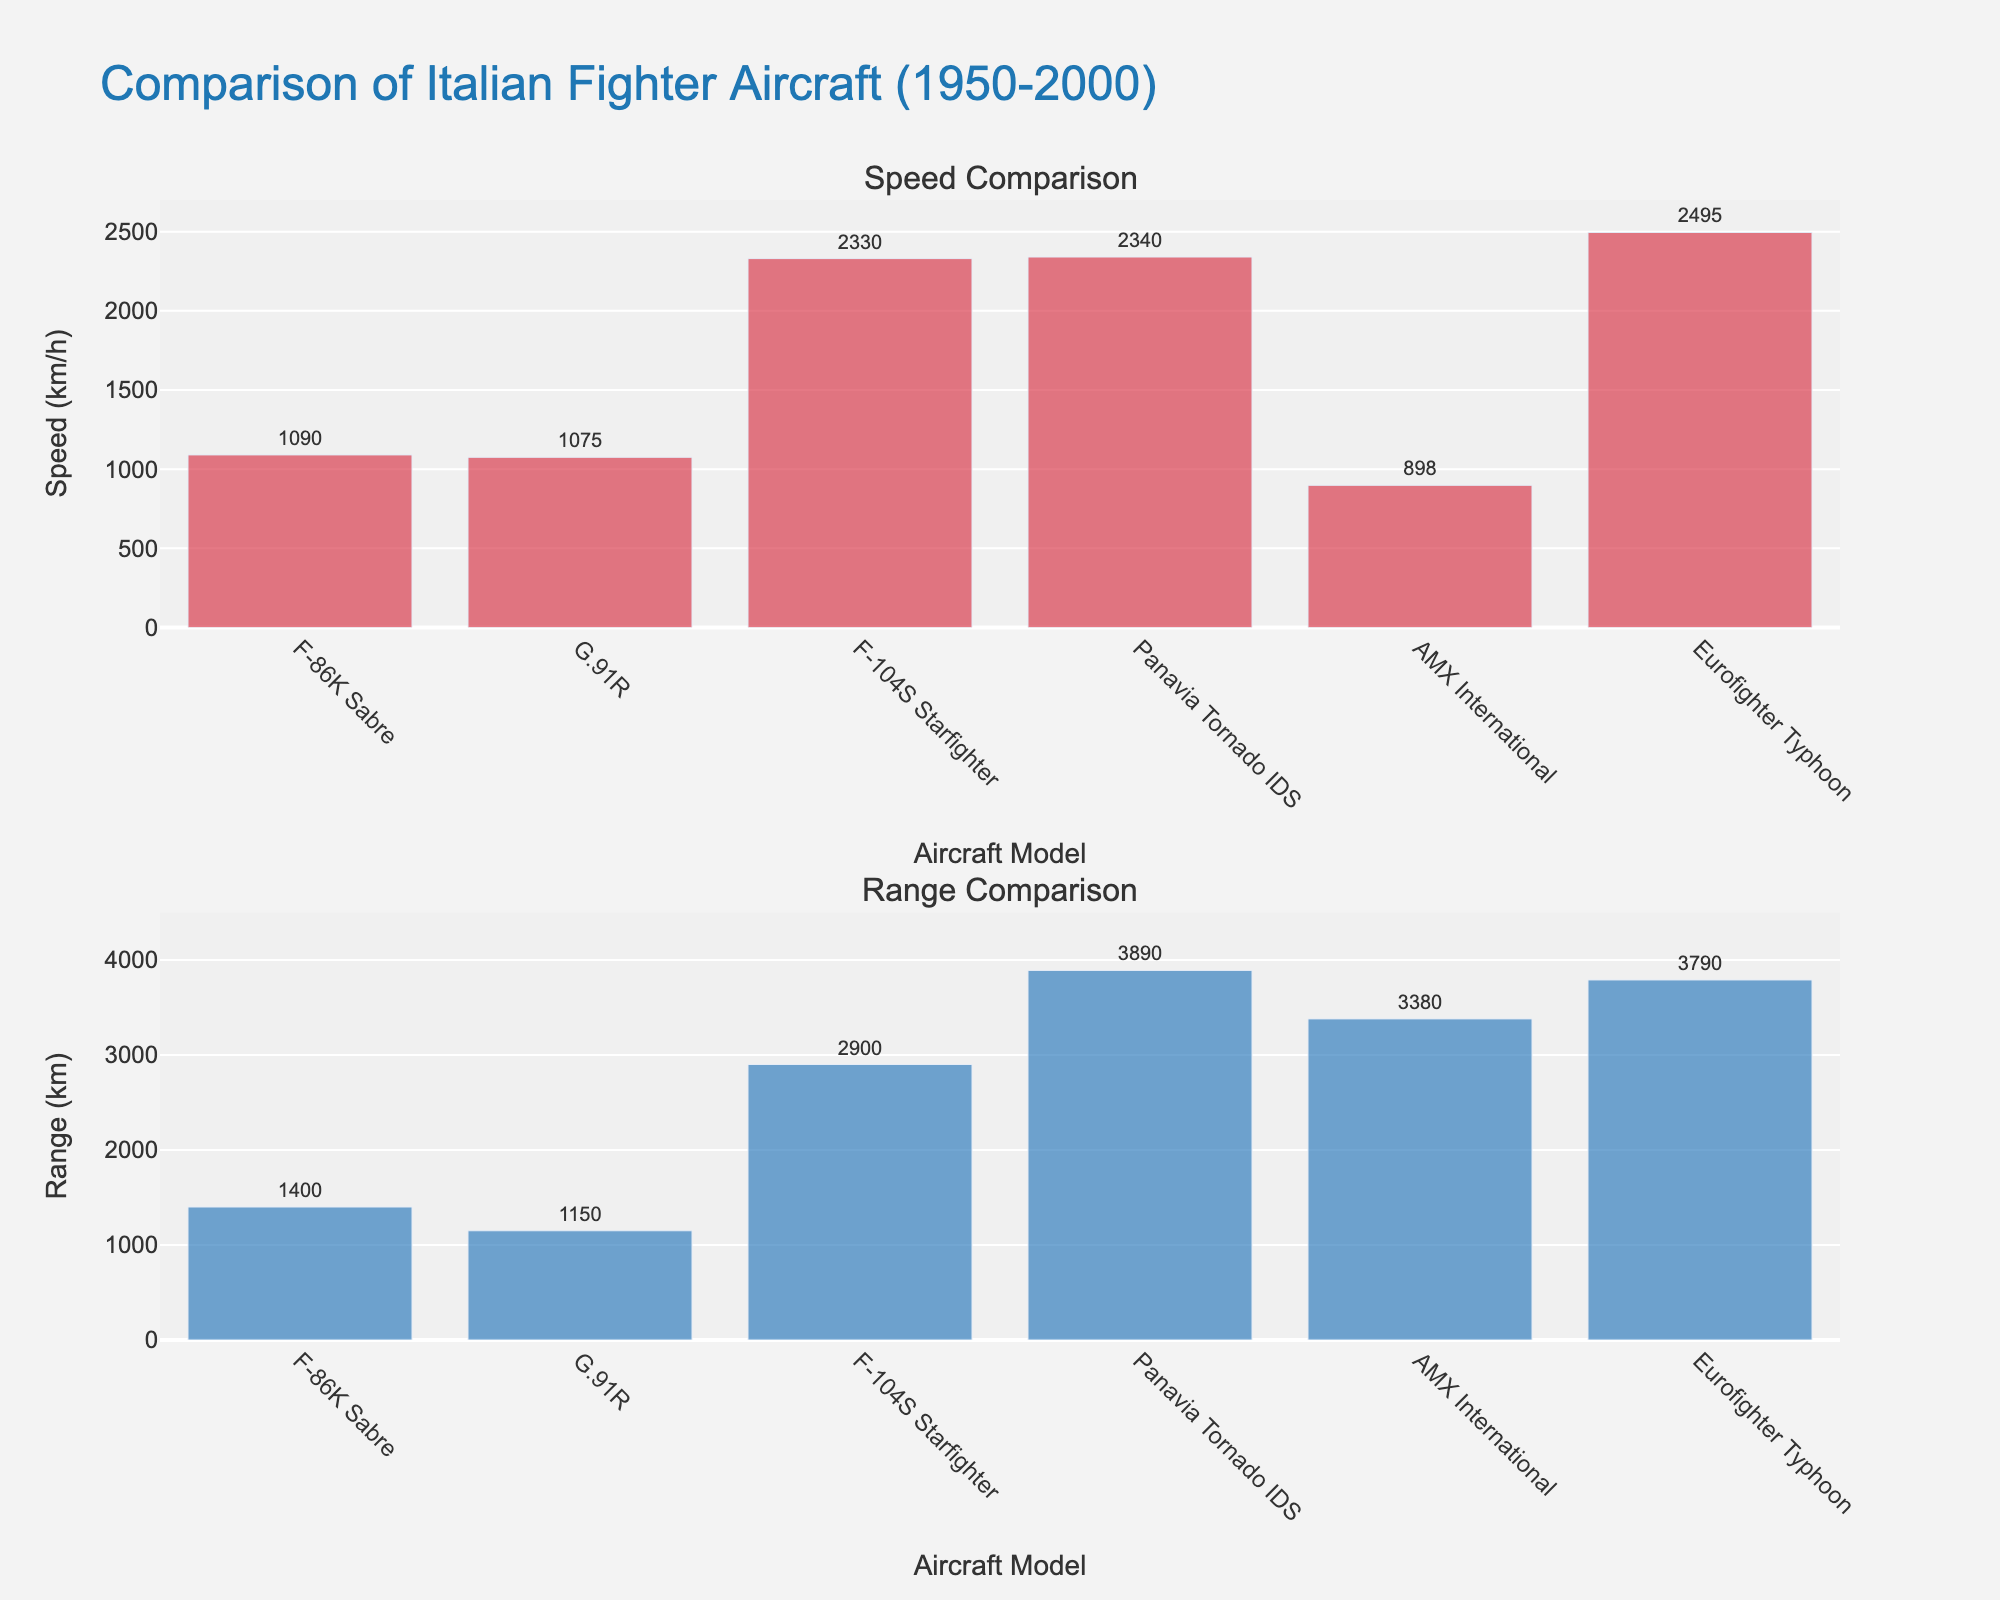What is the title of the figure? The title of the figure is displayed at the top and summarizes the main purpose of the figure. In this case, it reads "Comparison of Italian Fighter Aircraft (1950-2000)"
Answer: Comparison of Italian Fighter Aircraft (1950-2000) What are the two subplots in the figure comparing? The subplots are labeled at the top of each individual plot. The first subplot is titled "Speed Comparison," and the second subplot is titled "Range Comparison." They compare speed (km/h) and range (km) of different aircraft models
Answer: Speed and Range Which aircraft model has the highest speed? To determine the aircraft model with the highest speed, observe the top bar in the "Speed Comparison" subplot. The Eurofighter Typhoon has the tallest bar, indicating it has the highest speed of 2495 km/h
Answer: Eurofighter Typhoon What is the range of the Panavia Tornado IDS? To find the range of the Panavia Tornado IDS, locate its corresponding bar in the "Range Comparison" subplot and read the value shown outside the bar. It is 3890 km
Answer: 3890 km Among all aircraft models, which one has the lowest speed? In the "Speed Comparison" subplot, identify the shortest bar. The AMX International has the lowest speed, marked at 898 km/h
Answer: AMX International How does the speed of the F-86K Sabre compare to the F-104S Starfighter? Comparing the heights of the bars in the "Speed Comparison" subplot for these two models, the F-86K Sabre has a speed of 1090 km/h, whereas the F-104S Starfighter has a speed of 2330 km/h. Therefore, the F-104S Starfighter is faster
Answer: F-104S Starfighter is faster Which aircraft model from the 1990s has the highest range? Locate the aircraft models from the 1990s in the "Range Comparison" subplot. The AMX International has a range of 3380 km, which is higher than the range of any other model from the 1990s
Answer: AMX International Calculate the average speed of all aircraft models. To find the average speed, sum up the speeds of all aircraft models (1090 + 1075 + 2330 + 2340 + 898 + 2495) and divide by the number of models (6). The total is 10028 km/h, and dividing by 6 gives approximately 1671.33 km/h
Answer: 1671.33 km/h Which decade features the aircraft with the greatest range? To find the decade with the highest range, observe the "Range Comparison" subplot and identify the tallest bar. The Panavia Tornado IDS from the 1980s has the greatest range of 3890 km
Answer: 1980s Is there any decade in which aircraft models have both higher speed and higher range compared to the previous decade? Compare the bars in both subplots for subsequent decades. Notably, the 1980s Panavia Tornado IDS has both higher speed and range compared to the 1970s F-104S Starfighter, showing an increase in both attributes
Answer: 1980s 